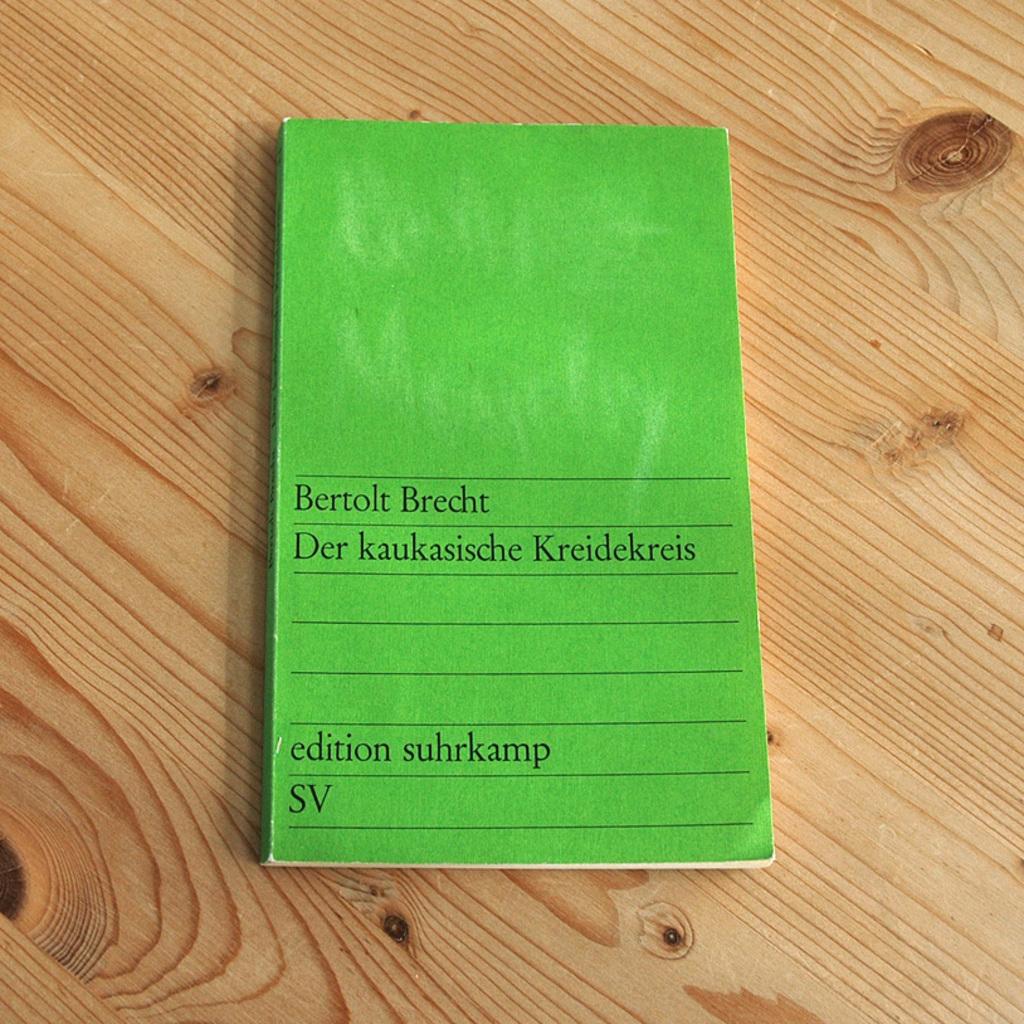Which edition is this?
Make the answer very short. Suhrkamp. 